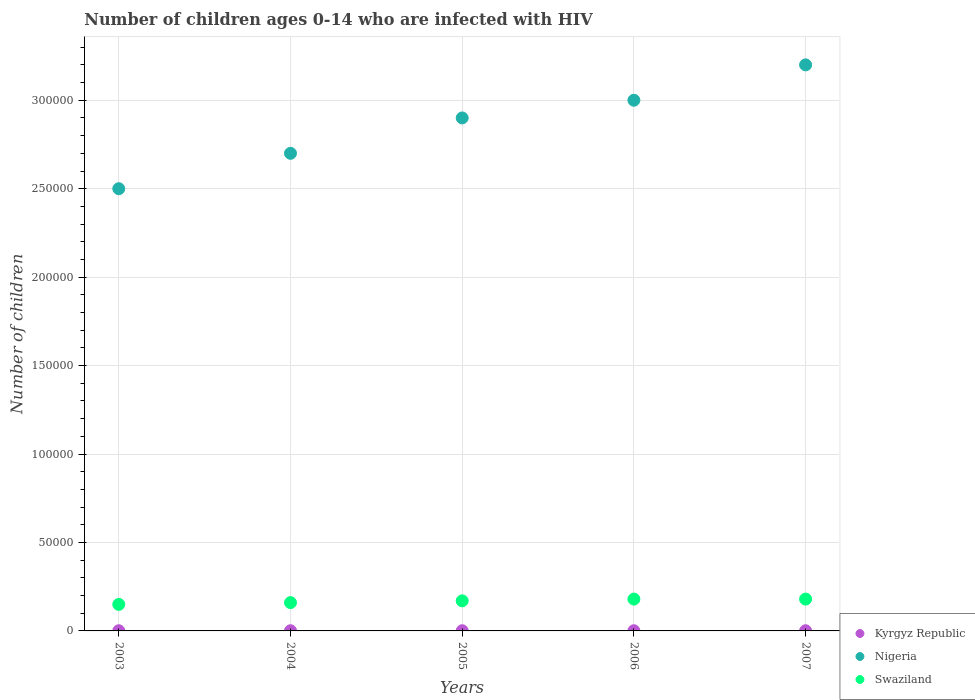What is the number of HIV infected children in Nigeria in 2006?
Your answer should be very brief. 3.00e+05. Across all years, what is the maximum number of HIV infected children in Swaziland?
Provide a short and direct response. 1.80e+04. Across all years, what is the minimum number of HIV infected children in Nigeria?
Keep it short and to the point. 2.50e+05. What is the total number of HIV infected children in Nigeria in the graph?
Provide a short and direct response. 1.43e+06. What is the difference between the number of HIV infected children in Nigeria in 2004 and that in 2007?
Your answer should be compact. -5.00e+04. What is the difference between the number of HIV infected children in Kyrgyz Republic in 2004 and the number of HIV infected children in Swaziland in 2007?
Provide a succinct answer. -1.79e+04. In the year 2003, what is the difference between the number of HIV infected children in Kyrgyz Republic and number of HIV infected children in Swaziland?
Offer a very short reply. -1.49e+04. Is the number of HIV infected children in Swaziland in 2004 less than that in 2006?
Give a very brief answer. Yes. Is the difference between the number of HIV infected children in Kyrgyz Republic in 2006 and 2007 greater than the difference between the number of HIV infected children in Swaziland in 2006 and 2007?
Give a very brief answer. No. What is the difference between the highest and the lowest number of HIV infected children in Swaziland?
Provide a short and direct response. 3000. Is the sum of the number of HIV infected children in Nigeria in 2006 and 2007 greater than the maximum number of HIV infected children in Swaziland across all years?
Provide a short and direct response. Yes. Is the number of HIV infected children in Kyrgyz Republic strictly greater than the number of HIV infected children in Nigeria over the years?
Your answer should be compact. No. Is the number of HIV infected children in Nigeria strictly less than the number of HIV infected children in Swaziland over the years?
Keep it short and to the point. No. How many dotlines are there?
Give a very brief answer. 3. Are the values on the major ticks of Y-axis written in scientific E-notation?
Your answer should be very brief. No. Does the graph contain grids?
Provide a succinct answer. Yes. Where does the legend appear in the graph?
Offer a very short reply. Bottom right. How many legend labels are there?
Provide a short and direct response. 3. What is the title of the graph?
Keep it short and to the point. Number of children ages 0-14 who are infected with HIV. What is the label or title of the X-axis?
Your response must be concise. Years. What is the label or title of the Y-axis?
Your response must be concise. Number of children. What is the Number of children in Swaziland in 2003?
Offer a very short reply. 1.50e+04. What is the Number of children in Kyrgyz Republic in 2004?
Make the answer very short. 100. What is the Number of children of Swaziland in 2004?
Make the answer very short. 1.60e+04. What is the Number of children in Nigeria in 2005?
Offer a very short reply. 2.90e+05. What is the Number of children in Swaziland in 2005?
Your response must be concise. 1.70e+04. What is the Number of children of Kyrgyz Republic in 2006?
Your answer should be compact. 100. What is the Number of children in Nigeria in 2006?
Provide a succinct answer. 3.00e+05. What is the Number of children of Swaziland in 2006?
Give a very brief answer. 1.80e+04. What is the Number of children in Kyrgyz Republic in 2007?
Ensure brevity in your answer.  100. What is the Number of children in Swaziland in 2007?
Provide a short and direct response. 1.80e+04. Across all years, what is the maximum Number of children of Kyrgyz Republic?
Provide a short and direct response. 100. Across all years, what is the maximum Number of children of Swaziland?
Offer a terse response. 1.80e+04. Across all years, what is the minimum Number of children in Nigeria?
Make the answer very short. 2.50e+05. Across all years, what is the minimum Number of children in Swaziland?
Ensure brevity in your answer.  1.50e+04. What is the total Number of children of Nigeria in the graph?
Provide a short and direct response. 1.43e+06. What is the total Number of children in Swaziland in the graph?
Keep it short and to the point. 8.40e+04. What is the difference between the Number of children in Swaziland in 2003 and that in 2004?
Give a very brief answer. -1000. What is the difference between the Number of children in Kyrgyz Republic in 2003 and that in 2005?
Keep it short and to the point. 0. What is the difference between the Number of children of Swaziland in 2003 and that in 2005?
Offer a terse response. -2000. What is the difference between the Number of children of Kyrgyz Republic in 2003 and that in 2006?
Give a very brief answer. 0. What is the difference between the Number of children in Swaziland in 2003 and that in 2006?
Ensure brevity in your answer.  -3000. What is the difference between the Number of children of Kyrgyz Republic in 2003 and that in 2007?
Provide a short and direct response. 0. What is the difference between the Number of children in Swaziland in 2003 and that in 2007?
Your answer should be compact. -3000. What is the difference between the Number of children in Nigeria in 2004 and that in 2005?
Make the answer very short. -2.00e+04. What is the difference between the Number of children of Swaziland in 2004 and that in 2005?
Keep it short and to the point. -1000. What is the difference between the Number of children of Kyrgyz Republic in 2004 and that in 2006?
Provide a succinct answer. 0. What is the difference between the Number of children of Swaziland in 2004 and that in 2006?
Give a very brief answer. -2000. What is the difference between the Number of children of Kyrgyz Republic in 2004 and that in 2007?
Your answer should be compact. 0. What is the difference between the Number of children of Swaziland in 2004 and that in 2007?
Ensure brevity in your answer.  -2000. What is the difference between the Number of children of Swaziland in 2005 and that in 2006?
Keep it short and to the point. -1000. What is the difference between the Number of children of Swaziland in 2005 and that in 2007?
Offer a very short reply. -1000. What is the difference between the Number of children of Kyrgyz Republic in 2006 and that in 2007?
Your answer should be very brief. 0. What is the difference between the Number of children of Nigeria in 2006 and that in 2007?
Ensure brevity in your answer.  -2.00e+04. What is the difference between the Number of children of Kyrgyz Republic in 2003 and the Number of children of Nigeria in 2004?
Keep it short and to the point. -2.70e+05. What is the difference between the Number of children of Kyrgyz Republic in 2003 and the Number of children of Swaziland in 2004?
Provide a succinct answer. -1.59e+04. What is the difference between the Number of children in Nigeria in 2003 and the Number of children in Swaziland in 2004?
Offer a terse response. 2.34e+05. What is the difference between the Number of children in Kyrgyz Republic in 2003 and the Number of children in Nigeria in 2005?
Ensure brevity in your answer.  -2.90e+05. What is the difference between the Number of children in Kyrgyz Republic in 2003 and the Number of children in Swaziland in 2005?
Offer a very short reply. -1.69e+04. What is the difference between the Number of children of Nigeria in 2003 and the Number of children of Swaziland in 2005?
Give a very brief answer. 2.33e+05. What is the difference between the Number of children in Kyrgyz Republic in 2003 and the Number of children in Nigeria in 2006?
Your answer should be very brief. -3.00e+05. What is the difference between the Number of children of Kyrgyz Republic in 2003 and the Number of children of Swaziland in 2006?
Your answer should be compact. -1.79e+04. What is the difference between the Number of children of Nigeria in 2003 and the Number of children of Swaziland in 2006?
Provide a succinct answer. 2.32e+05. What is the difference between the Number of children in Kyrgyz Republic in 2003 and the Number of children in Nigeria in 2007?
Keep it short and to the point. -3.20e+05. What is the difference between the Number of children in Kyrgyz Republic in 2003 and the Number of children in Swaziland in 2007?
Offer a terse response. -1.79e+04. What is the difference between the Number of children in Nigeria in 2003 and the Number of children in Swaziland in 2007?
Your response must be concise. 2.32e+05. What is the difference between the Number of children of Kyrgyz Republic in 2004 and the Number of children of Nigeria in 2005?
Offer a very short reply. -2.90e+05. What is the difference between the Number of children of Kyrgyz Republic in 2004 and the Number of children of Swaziland in 2005?
Ensure brevity in your answer.  -1.69e+04. What is the difference between the Number of children of Nigeria in 2004 and the Number of children of Swaziland in 2005?
Offer a terse response. 2.53e+05. What is the difference between the Number of children in Kyrgyz Republic in 2004 and the Number of children in Nigeria in 2006?
Offer a very short reply. -3.00e+05. What is the difference between the Number of children of Kyrgyz Republic in 2004 and the Number of children of Swaziland in 2006?
Your answer should be compact. -1.79e+04. What is the difference between the Number of children of Nigeria in 2004 and the Number of children of Swaziland in 2006?
Make the answer very short. 2.52e+05. What is the difference between the Number of children of Kyrgyz Republic in 2004 and the Number of children of Nigeria in 2007?
Offer a very short reply. -3.20e+05. What is the difference between the Number of children in Kyrgyz Republic in 2004 and the Number of children in Swaziland in 2007?
Make the answer very short. -1.79e+04. What is the difference between the Number of children in Nigeria in 2004 and the Number of children in Swaziland in 2007?
Make the answer very short. 2.52e+05. What is the difference between the Number of children in Kyrgyz Republic in 2005 and the Number of children in Nigeria in 2006?
Provide a succinct answer. -3.00e+05. What is the difference between the Number of children in Kyrgyz Republic in 2005 and the Number of children in Swaziland in 2006?
Your answer should be very brief. -1.79e+04. What is the difference between the Number of children in Nigeria in 2005 and the Number of children in Swaziland in 2006?
Your answer should be very brief. 2.72e+05. What is the difference between the Number of children of Kyrgyz Republic in 2005 and the Number of children of Nigeria in 2007?
Offer a terse response. -3.20e+05. What is the difference between the Number of children in Kyrgyz Republic in 2005 and the Number of children in Swaziland in 2007?
Your response must be concise. -1.79e+04. What is the difference between the Number of children in Nigeria in 2005 and the Number of children in Swaziland in 2007?
Offer a terse response. 2.72e+05. What is the difference between the Number of children of Kyrgyz Republic in 2006 and the Number of children of Nigeria in 2007?
Provide a short and direct response. -3.20e+05. What is the difference between the Number of children of Kyrgyz Republic in 2006 and the Number of children of Swaziland in 2007?
Your response must be concise. -1.79e+04. What is the difference between the Number of children in Nigeria in 2006 and the Number of children in Swaziland in 2007?
Offer a very short reply. 2.82e+05. What is the average Number of children of Nigeria per year?
Make the answer very short. 2.86e+05. What is the average Number of children in Swaziland per year?
Offer a very short reply. 1.68e+04. In the year 2003, what is the difference between the Number of children of Kyrgyz Republic and Number of children of Nigeria?
Keep it short and to the point. -2.50e+05. In the year 2003, what is the difference between the Number of children of Kyrgyz Republic and Number of children of Swaziland?
Your answer should be compact. -1.49e+04. In the year 2003, what is the difference between the Number of children of Nigeria and Number of children of Swaziland?
Provide a short and direct response. 2.35e+05. In the year 2004, what is the difference between the Number of children in Kyrgyz Republic and Number of children in Nigeria?
Provide a short and direct response. -2.70e+05. In the year 2004, what is the difference between the Number of children in Kyrgyz Republic and Number of children in Swaziland?
Provide a short and direct response. -1.59e+04. In the year 2004, what is the difference between the Number of children in Nigeria and Number of children in Swaziland?
Your response must be concise. 2.54e+05. In the year 2005, what is the difference between the Number of children in Kyrgyz Republic and Number of children in Nigeria?
Offer a terse response. -2.90e+05. In the year 2005, what is the difference between the Number of children in Kyrgyz Republic and Number of children in Swaziland?
Make the answer very short. -1.69e+04. In the year 2005, what is the difference between the Number of children in Nigeria and Number of children in Swaziland?
Provide a succinct answer. 2.73e+05. In the year 2006, what is the difference between the Number of children in Kyrgyz Republic and Number of children in Nigeria?
Keep it short and to the point. -3.00e+05. In the year 2006, what is the difference between the Number of children of Kyrgyz Republic and Number of children of Swaziland?
Give a very brief answer. -1.79e+04. In the year 2006, what is the difference between the Number of children in Nigeria and Number of children in Swaziland?
Ensure brevity in your answer.  2.82e+05. In the year 2007, what is the difference between the Number of children of Kyrgyz Republic and Number of children of Nigeria?
Ensure brevity in your answer.  -3.20e+05. In the year 2007, what is the difference between the Number of children in Kyrgyz Republic and Number of children in Swaziland?
Your answer should be very brief. -1.79e+04. In the year 2007, what is the difference between the Number of children in Nigeria and Number of children in Swaziland?
Provide a short and direct response. 3.02e+05. What is the ratio of the Number of children of Kyrgyz Republic in 2003 to that in 2004?
Offer a terse response. 1. What is the ratio of the Number of children of Nigeria in 2003 to that in 2004?
Your answer should be very brief. 0.93. What is the ratio of the Number of children in Swaziland in 2003 to that in 2004?
Offer a very short reply. 0.94. What is the ratio of the Number of children in Kyrgyz Republic in 2003 to that in 2005?
Give a very brief answer. 1. What is the ratio of the Number of children of Nigeria in 2003 to that in 2005?
Give a very brief answer. 0.86. What is the ratio of the Number of children in Swaziland in 2003 to that in 2005?
Offer a terse response. 0.88. What is the ratio of the Number of children in Nigeria in 2003 to that in 2006?
Provide a succinct answer. 0.83. What is the ratio of the Number of children in Nigeria in 2003 to that in 2007?
Provide a short and direct response. 0.78. What is the ratio of the Number of children in Kyrgyz Republic in 2004 to that in 2005?
Offer a very short reply. 1. What is the ratio of the Number of children of Swaziland in 2004 to that in 2005?
Offer a terse response. 0.94. What is the ratio of the Number of children of Kyrgyz Republic in 2004 to that in 2006?
Your answer should be very brief. 1. What is the ratio of the Number of children of Nigeria in 2004 to that in 2007?
Provide a succinct answer. 0.84. What is the ratio of the Number of children in Swaziland in 2004 to that in 2007?
Offer a terse response. 0.89. What is the ratio of the Number of children of Nigeria in 2005 to that in 2006?
Your answer should be compact. 0.97. What is the ratio of the Number of children in Swaziland in 2005 to that in 2006?
Make the answer very short. 0.94. What is the ratio of the Number of children of Nigeria in 2005 to that in 2007?
Offer a very short reply. 0.91. What is the difference between the highest and the second highest Number of children of Kyrgyz Republic?
Give a very brief answer. 0. What is the difference between the highest and the second highest Number of children in Swaziland?
Your answer should be compact. 0. What is the difference between the highest and the lowest Number of children in Swaziland?
Offer a terse response. 3000. 